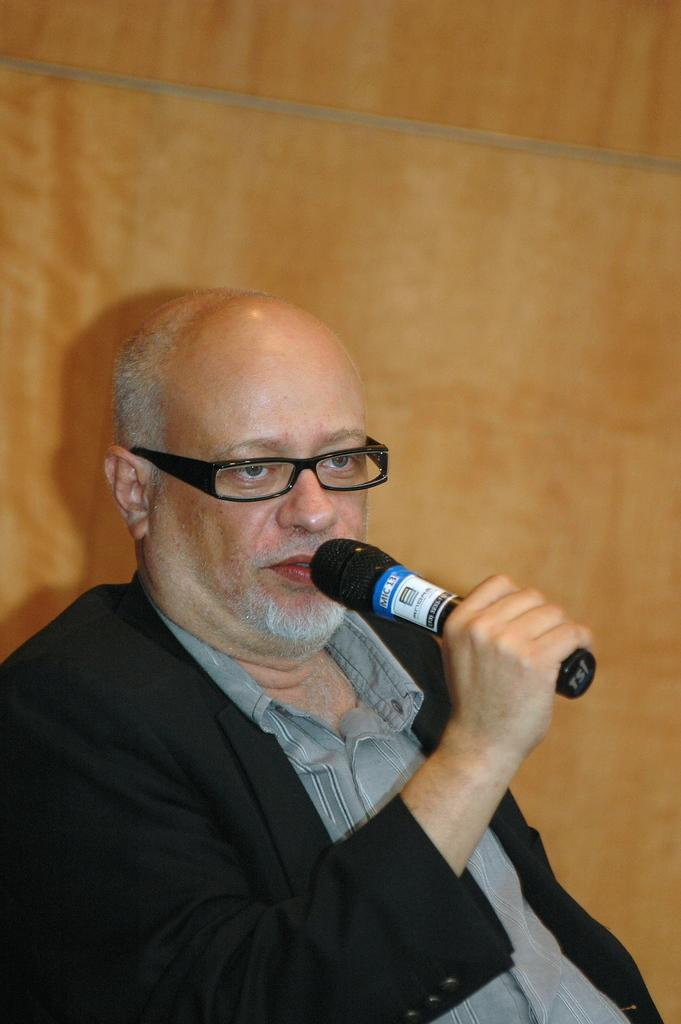Who is the main subject in the image? There is a man in the image. What is the man doing in the image? The man is speaking in the image. What object is the man holding while speaking? The man is holding a microphone in the image. What can be seen in the background of the image? There is a wooden wall in the background of the image. What type of berry is the man eating in the image? There is no berry present in the image, and the man is not eating anything. 